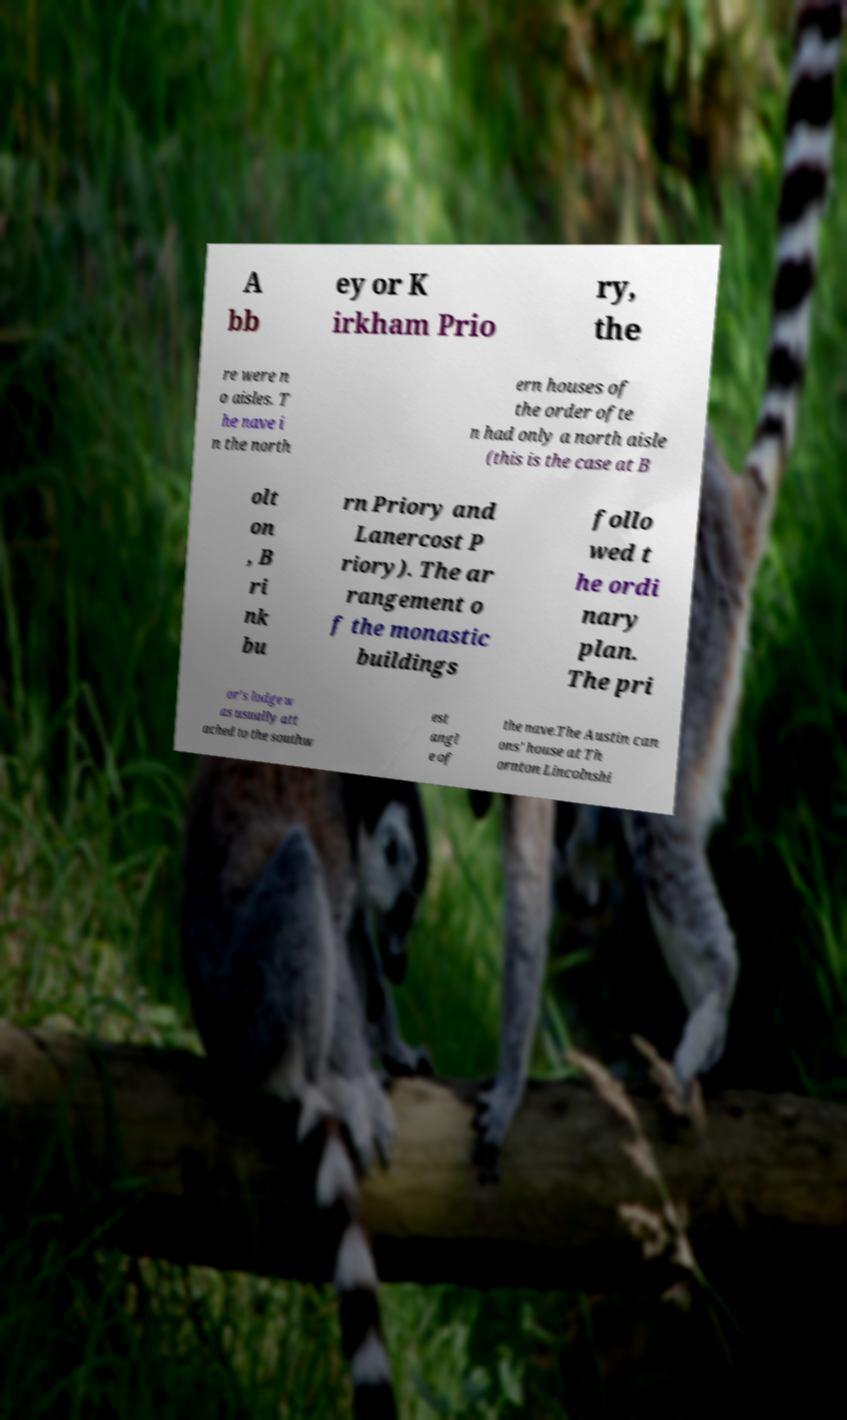Can you accurately transcribe the text from the provided image for me? A bb ey or K irkham Prio ry, the re were n o aisles. T he nave i n the north ern houses of the order ofte n had only a north aisle (this is the case at B olt on , B ri nk bu rn Priory and Lanercost P riory). The ar rangement o f the monastic buildings follo wed t he ordi nary plan. The pri or's lodge w as usually att ached to the southw est angl e of the nave.The Austin can ons' house at Th ornton Lincolnshi 